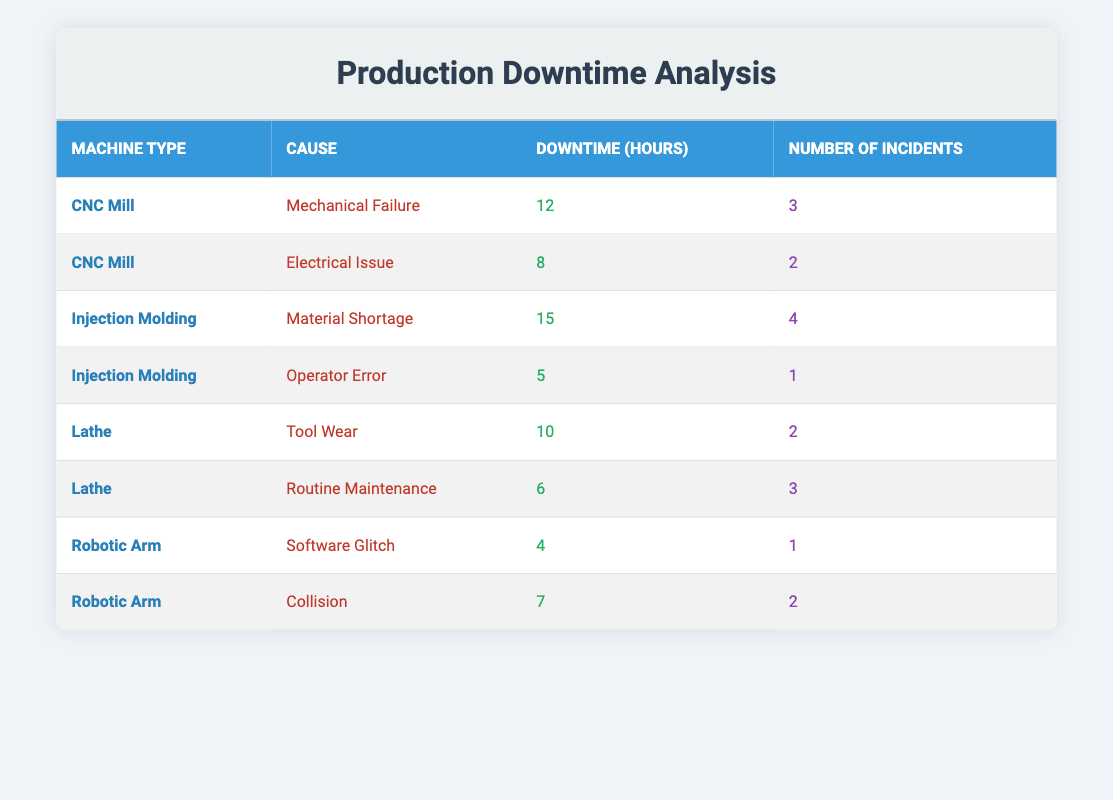What is the total downtime caused by Mechanical Failure for CNC Mills? The table shows that Mechanical Failure leads to 12 hours of downtime for CNC Mills. There is only one entry for this cause and machine type. Therefore, the total downtime for this specific entry is simply 12 hours.
Answer: 12 hours Which machine type has the highest total downtime hours? To find the machine type with the highest total downtime, we sum the downtime hours for each machine type. For CNC Mills, the total downtime is 12 + 8 = 20 hours. For Injection Molding, it's 15 + 5 = 20 hours. For Lathe, it's 10 + 6 = 16 hours. For Robotic Arm, it's 4 + 7 = 11 hours. CNC Mills and Injection Molding both have the highest total downtime at 20 hours.
Answer: CNC Mill and Injection Molding Is there a downtime incident related to Operator Error in the table? The table includes Operator Error as a cause of downtime under the Injection Molding machine type, which has 5 hours of downtime and 1 incident recorded. Thus, there is indeed a related incident.
Answer: Yes What is the average downtime for the Robotic Arm incidents? The Robotic Arm has two causes of downtime: Software Glitch (4 hours) and Collision (7 hours). To find the average, we add these downtimes: 4 + 7 = 11 hours total, and since there are 2 incidents, we divide 11 by 2, resulting in an average downtime of 5.5 hours.
Answer: 5.5 hours How many total incidents are recorded for the Lathe machine type? The Lathe has two causes of downtime in the table: Tool Wear (2 incidents) and Routine Maintenance (3 incidents). To find the total incidents, we sum these two numbers: 2 + 3 = 5 incidents overall for the Lathe machine type.
Answer: 5 incidents What machine type has more incidents due to Electrical Issues than Mechanical Failures? In the table, CNC Mills have 2 incidents due to Electrical Issues and 3 incidents due to Mechanical Failures. Since the number of incidents for Electrical Issues (2) is not higher than for Mechanical Failures (3), there is no machine type with more incidents for Electrical Issues compared to Mechanical Failures.
Answer: No What is the total downtime for the Injection Molding machine type? The Injection Molding machine type has 2 entries: Material Shortage (15 hours) and Operator Error (5 hours). To find total downtime, we add these two values: 15 + 5 = 20 hours. Therefore, the total downtime for Injection Molding is 20 hours.
Answer: 20 hours Are there any incidents of downtime caused by Collision in the table? Yes, the table has an entry for Collision under the Robotic Arm, which is noted to have 7 hours of downtime and 2 incidents. Therefore, there are indeed incidents caused by Collision.
Answer: Yes What is the difference in downtime caused by Tool Wear versus Routine Maintenance for the Lathe? The downtime caused by Tool Wear is 10 hours, while the downtime caused by Routine Maintenance is 6 hours. To find the difference, we subtract the Routine Maintenance downtime from Tool Wear: 10 - 6 = 4 hours. Therefore, the difference in downtime is 4 hours.
Answer: 4 hours 